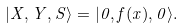Convert formula to latex. <formula><loc_0><loc_0><loc_500><loc_500>| X , Y , S \rangle = | 0 , f ( x ) , 0 \rangle .</formula> 